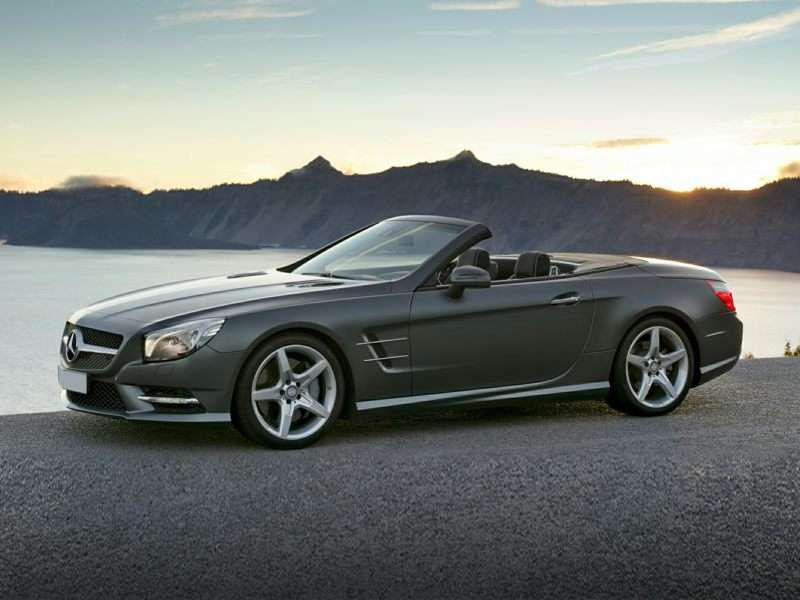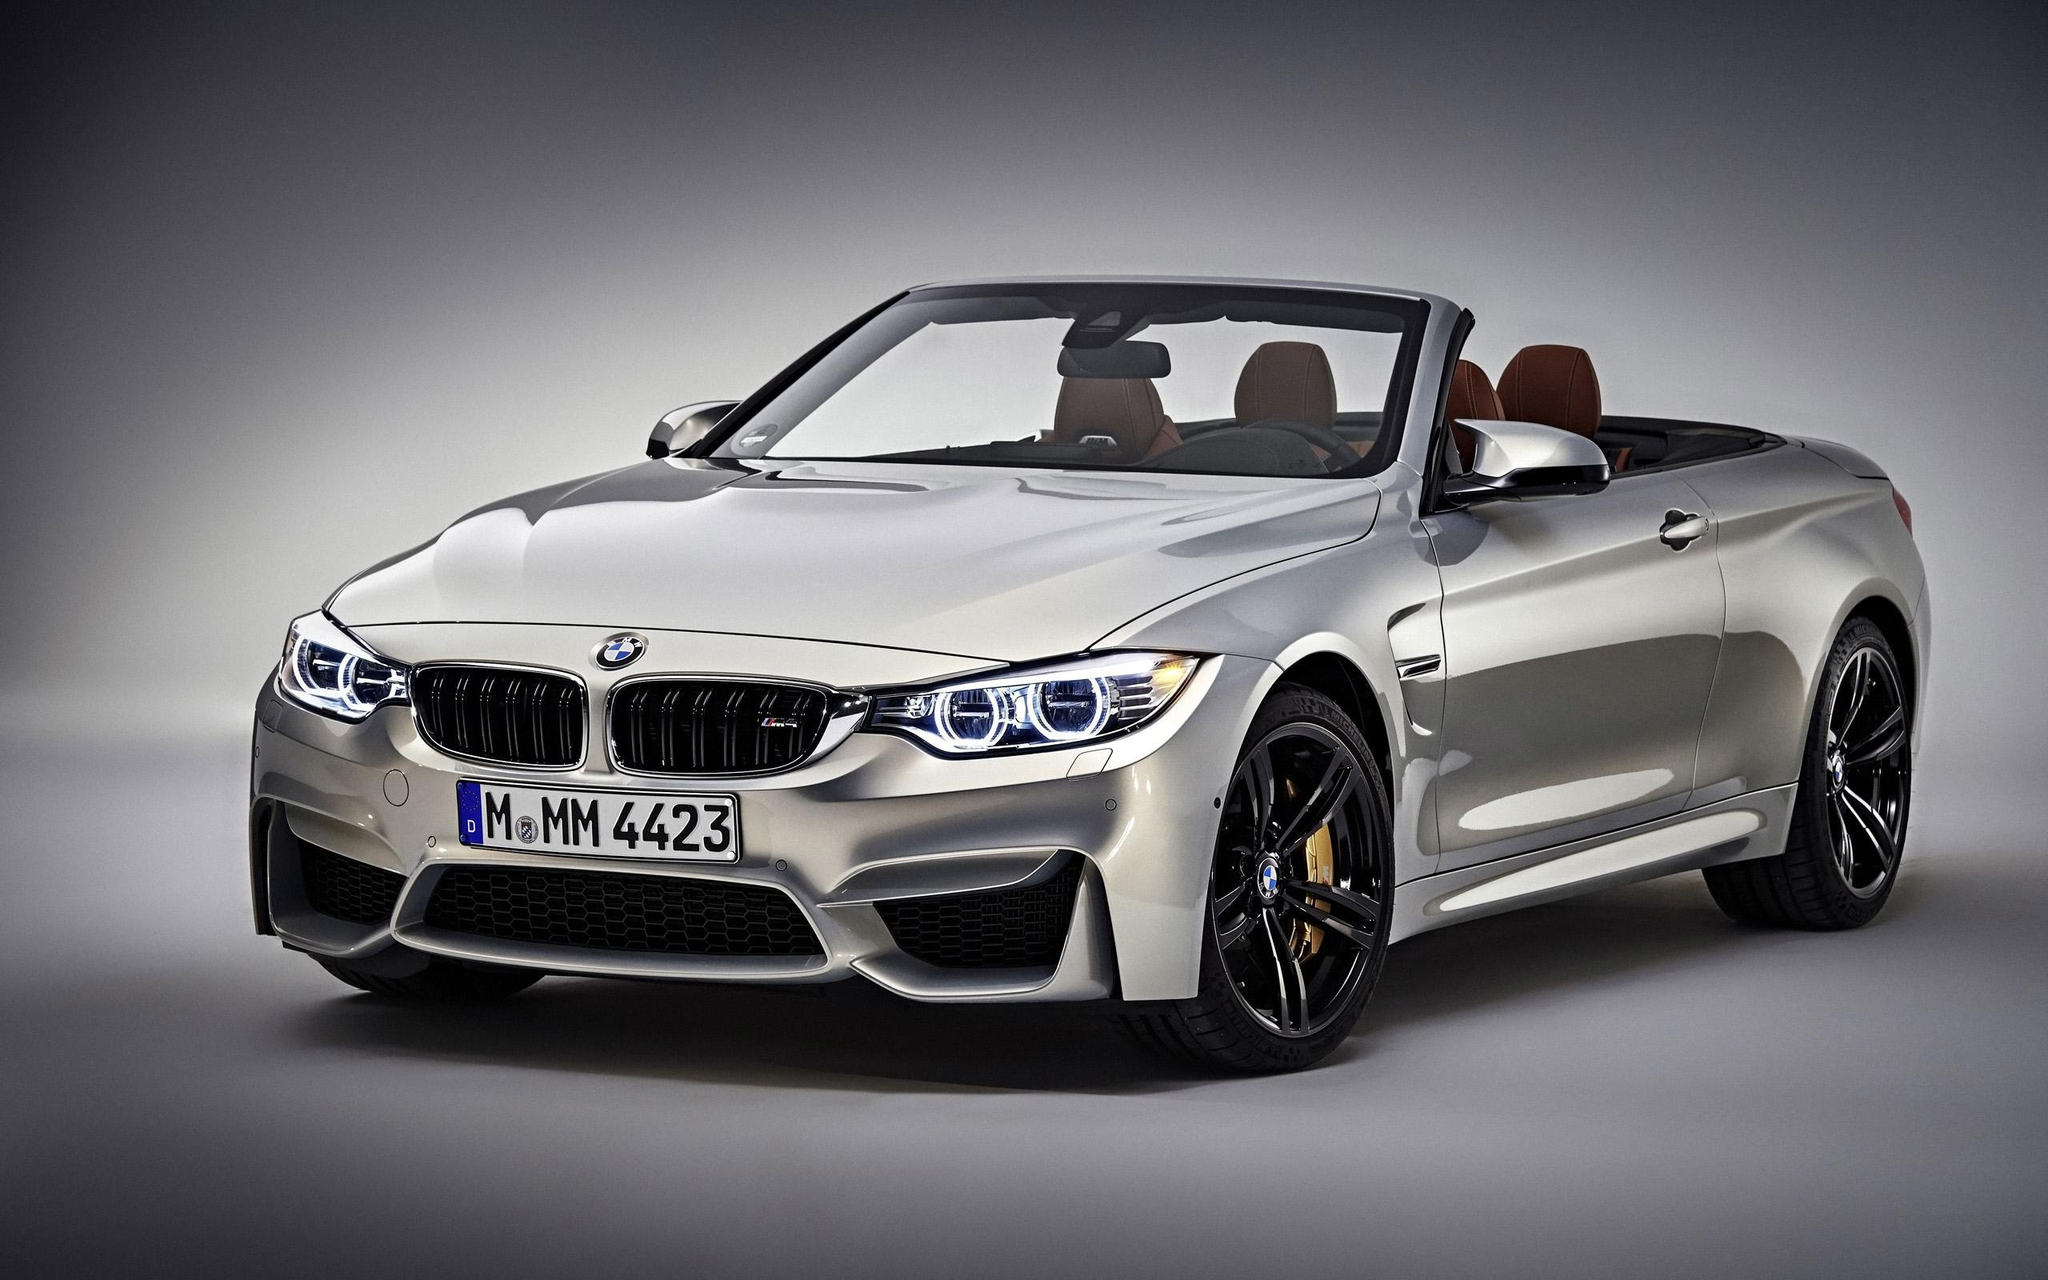The first image is the image on the left, the second image is the image on the right. Analyze the images presented: Is the assertion "The cars in the left and right images are each turned leftward, and one car is pictured in front of water and peaks of land." valid? Answer yes or no. Yes. The first image is the image on the left, the second image is the image on the right. Evaluate the accuracy of this statement regarding the images: "Two convertibles with visible headrests, one of them with chrome wheels, are parked and angled in the same direction.". Is it true? Answer yes or no. Yes. 